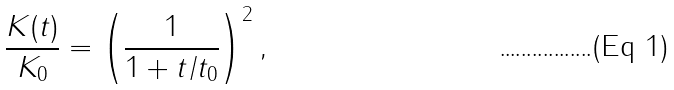<formula> <loc_0><loc_0><loc_500><loc_500>\frac { K ( t ) } { K _ { 0 } } = \left ( \frac { 1 } { 1 + t / t _ { 0 } } \right ) ^ { 2 } ,</formula> 